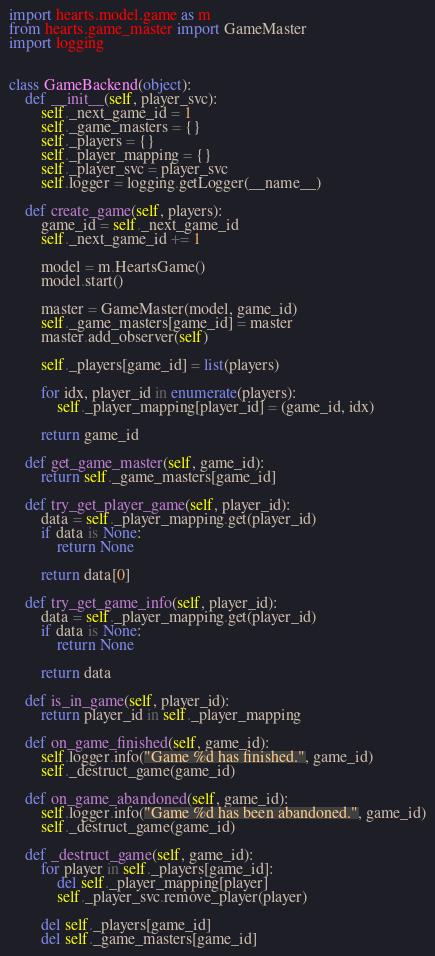Convert code to text. <code><loc_0><loc_0><loc_500><loc_500><_Python_>import hearts.model.game as m
from hearts.game_master import GameMaster
import logging


class GameBackend(object):
    def __init__(self, player_svc):
        self._next_game_id = 1
        self._game_masters = {}
        self._players = {}
        self._player_mapping = {}
        self._player_svc = player_svc
        self.logger = logging.getLogger(__name__)

    def create_game(self, players):
        game_id = self._next_game_id
        self._next_game_id += 1

        model = m.HeartsGame()
        model.start()

        master = GameMaster(model, game_id)
        self._game_masters[game_id] = master
        master.add_observer(self)

        self._players[game_id] = list(players)

        for idx, player_id in enumerate(players):
            self._player_mapping[player_id] = (game_id, idx)

        return game_id

    def get_game_master(self, game_id):
        return self._game_masters[game_id]

    def try_get_player_game(self, player_id):
        data = self._player_mapping.get(player_id)
        if data is None:
            return None

        return data[0]

    def try_get_game_info(self, player_id):
        data = self._player_mapping.get(player_id)
        if data is None:
            return None

        return data

    def is_in_game(self, player_id):
        return player_id in self._player_mapping

    def on_game_finished(self, game_id):
        self.logger.info("Game %d has finished.", game_id)
        self._destruct_game(game_id)

    def on_game_abandoned(self, game_id):
        self.logger.info("Game %d has been abandoned.", game_id)
        self._destruct_game(game_id)

    def _destruct_game(self, game_id):
        for player in self._players[game_id]:
            del self._player_mapping[player]
            self._player_svc.remove_player(player)

        del self._players[game_id]
        del self._game_masters[game_id]</code> 